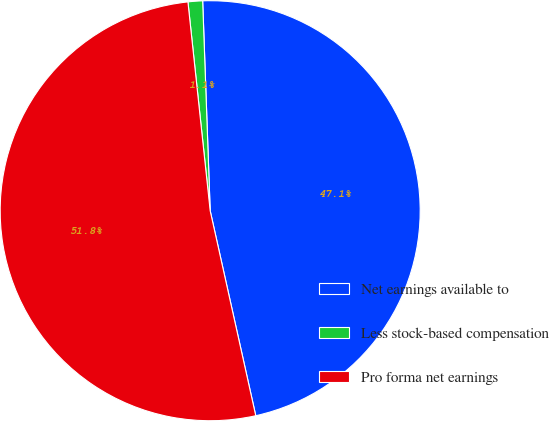<chart> <loc_0><loc_0><loc_500><loc_500><pie_chart><fcel>Net earnings available to<fcel>Less stock-based compensation<fcel>Pro forma net earnings<nl><fcel>47.09%<fcel>1.12%<fcel>51.8%<nl></chart> 